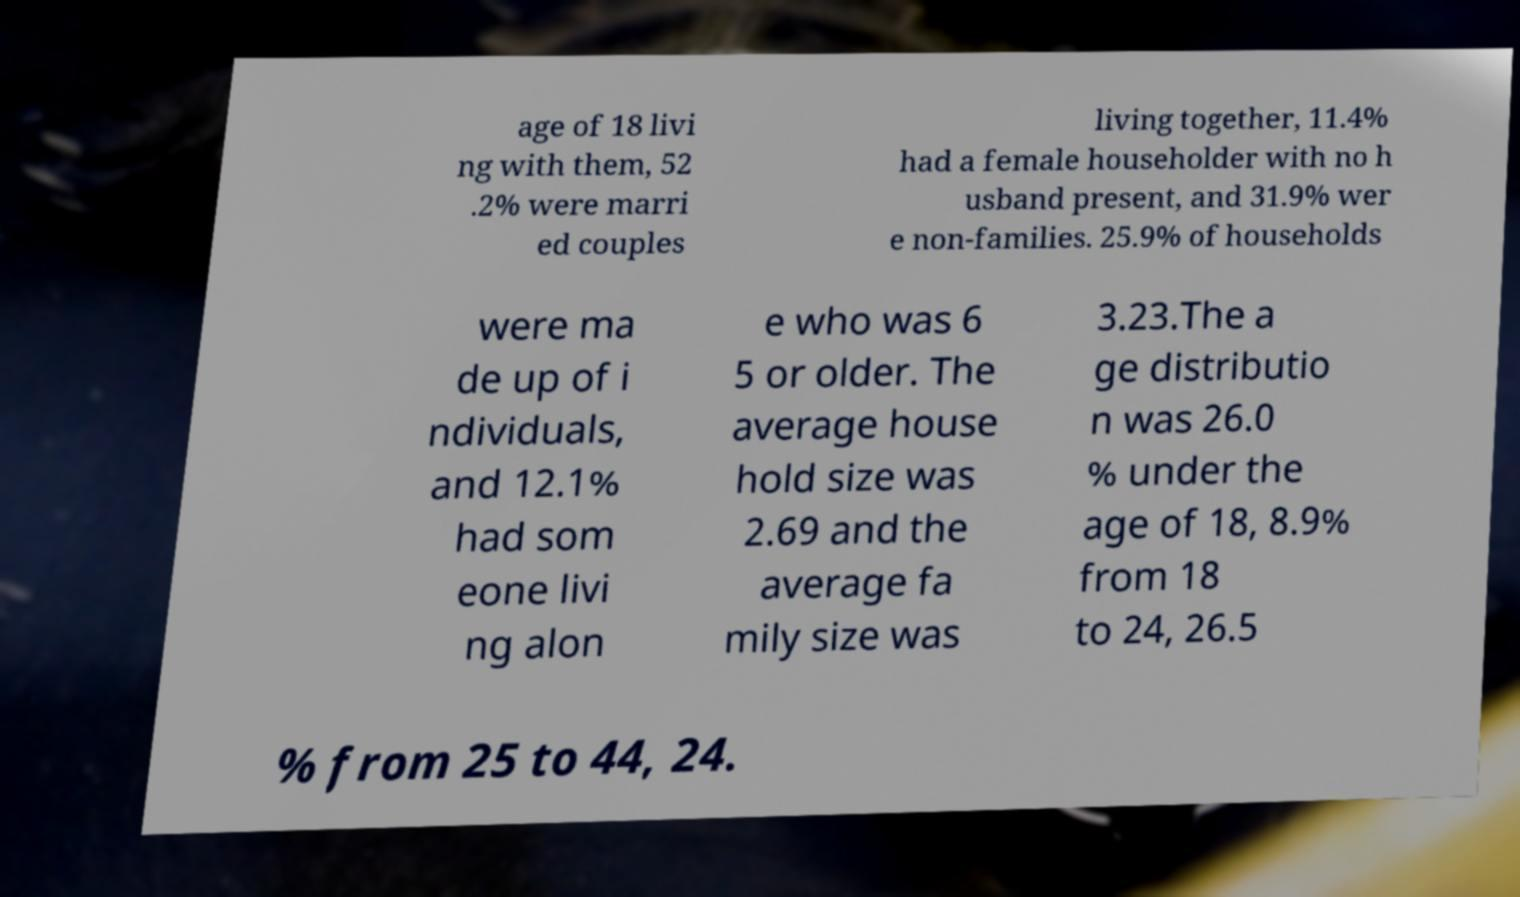There's text embedded in this image that I need extracted. Can you transcribe it verbatim? age of 18 livi ng with them, 52 .2% were marri ed couples living together, 11.4% had a female householder with no h usband present, and 31.9% wer e non-families. 25.9% of households were ma de up of i ndividuals, and 12.1% had som eone livi ng alon e who was 6 5 or older. The average house hold size was 2.69 and the average fa mily size was 3.23.The a ge distributio n was 26.0 % under the age of 18, 8.9% from 18 to 24, 26.5 % from 25 to 44, 24. 